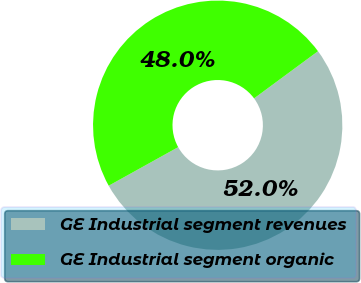Convert chart to OTSL. <chart><loc_0><loc_0><loc_500><loc_500><pie_chart><fcel>GE Industrial segment revenues<fcel>GE Industrial segment organic<nl><fcel>52.05%<fcel>47.95%<nl></chart> 